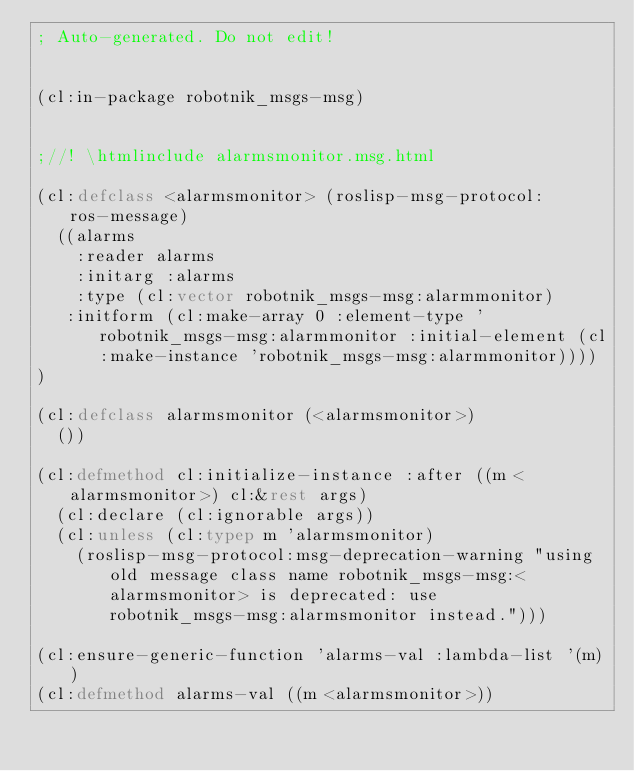Convert code to text. <code><loc_0><loc_0><loc_500><loc_500><_Lisp_>; Auto-generated. Do not edit!


(cl:in-package robotnik_msgs-msg)


;//! \htmlinclude alarmsmonitor.msg.html

(cl:defclass <alarmsmonitor> (roslisp-msg-protocol:ros-message)
  ((alarms
    :reader alarms
    :initarg :alarms
    :type (cl:vector robotnik_msgs-msg:alarmmonitor)
   :initform (cl:make-array 0 :element-type 'robotnik_msgs-msg:alarmmonitor :initial-element (cl:make-instance 'robotnik_msgs-msg:alarmmonitor))))
)

(cl:defclass alarmsmonitor (<alarmsmonitor>)
  ())

(cl:defmethod cl:initialize-instance :after ((m <alarmsmonitor>) cl:&rest args)
  (cl:declare (cl:ignorable args))
  (cl:unless (cl:typep m 'alarmsmonitor)
    (roslisp-msg-protocol:msg-deprecation-warning "using old message class name robotnik_msgs-msg:<alarmsmonitor> is deprecated: use robotnik_msgs-msg:alarmsmonitor instead.")))

(cl:ensure-generic-function 'alarms-val :lambda-list '(m))
(cl:defmethod alarms-val ((m <alarmsmonitor>))</code> 